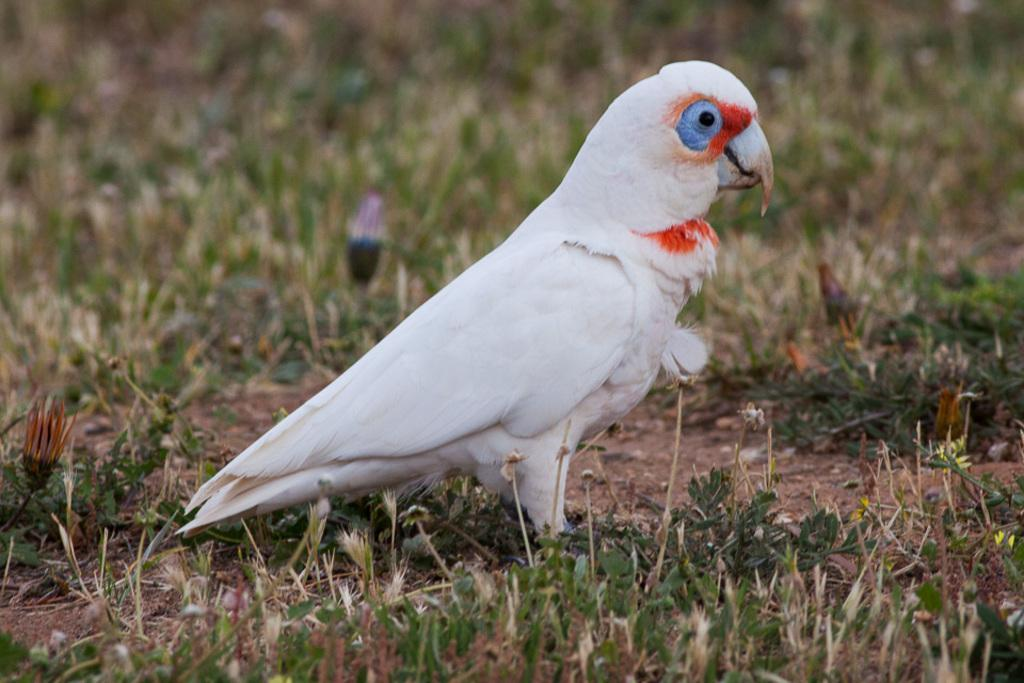What type of animal can be seen in the image? There is a white color bird in the image. Where is the bird located in the image? The bird is standing on the grass. What is the surface beneath the bird? The grass is on the ground. What other types of plants are visible in the image? There are plants with flowers in the image. How would you describe the background of the image? The background of the image is blurred. What type of scissors can be seen cutting the grass in the image? There are no scissors present in the image; the bird is standing on the grass. How many birds are in the flock in the image? There is only one bird visible in the image, so there is no flock present. 